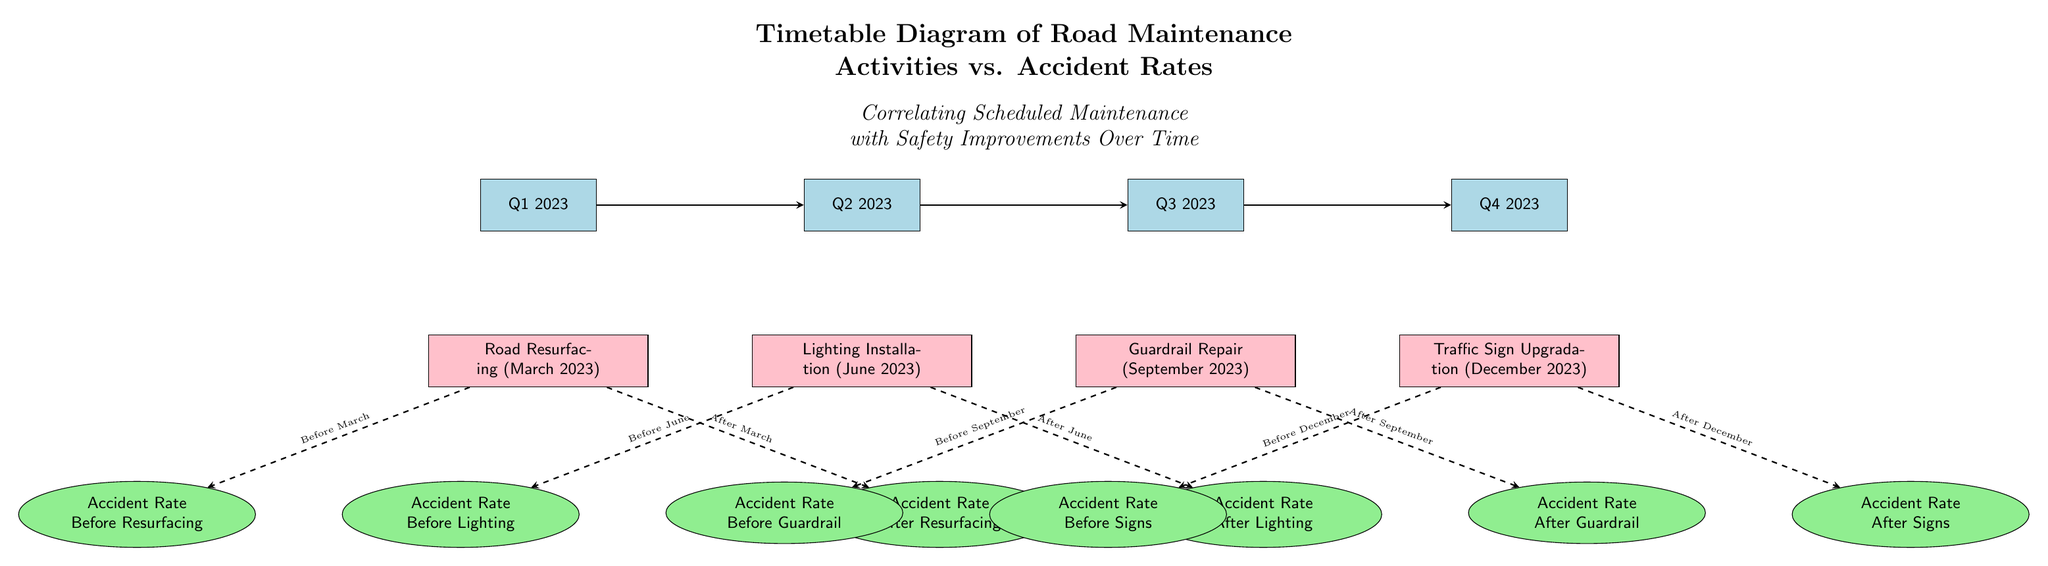What activities are scheduled in Q1 2023? The diagram shows a node for Q1 2023 with a direct connection to the activity "Road Resurfacing (March 2023)" positioned below it, indicating that this activity is scheduled for Q1 2023.
Answer: Road Resurfacing (March 2023) How many maintenance activities are scheduled after Q3 2023? In the diagram, there is one activity scheduled for Q4 2023, namely "Traffic Sign Upgradation (December 2023)". This indicates that it is the only maintenance activity planned after Q3 2023.
Answer: 1 What is the accident rate before the lighting installation? The node connected to the lighting installation activity is "Accident Rate Before Lighting", which is positioned left of the "Lighting Installation (June 2023)" node. This specifies the accident rate immediately prior to this particular maintenance action.
Answer: Accident Rate Before Lighting What is the last maintenance activity on the diagram? The flow of the diagram indicates that the last maintenance activity displayed is "Traffic Sign Upgradation (December 2023)", which is the only activity listed under the Q4 2023 time period.
Answer: Traffic Sign Upgradation (December 2023) Which activity corresponds to the accident rate after resurfacing? Below the "Road Resurfacing (March 2023)" node is another node labeled "Accident Rate After Resurfacing", which directly correlates with safety improvements following this specific maintenance activity.
Answer: Accident Rate After Resurfacing What is the relationship between road resurfacing and accident rates? The diagram illustrates that road resurfacing leads to a reduction in accident rates, with direct arrows indicating a flow from the activity to both the "Accident Rate Before Resurfacing" and "Accident Rate After Resurfacing" nodes, thus showing how maintenance can influence safety over time.
Answer: Reduction in accident rates What safety improvement follows the guardrail repair? The node labeled "Accident Rate After Guardrail" is shown as the result of the guardrail repair activity scheduled for September 2023, demonstrating the impact of this maintenance on safety.
Answer: Accident Rate After Guardrail How many accident rate nodes are shown in the diagram? By counting each unique accident rate node in the diagram, we find four: "Accident Rate Before Resurfacing", "Accident Rate After Resurfacing", "Accident Rate Before Lighting", "Accident Rate After Lighting", and others; totaling eight accident rate related nodes.
Answer: 8 Which quarter is associated with the earliest recorded maintenance activity? The earliest recorded maintenance activity in the diagram is "Road Resurfacing (March 2023)", which is scheduled in Q1 2023, making it the first quarter associated with any maintenance activity in the diagram.
Answer: Q1 2023 